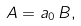<formula> <loc_0><loc_0><loc_500><loc_500>A = a _ { 0 } \, B ,</formula> 